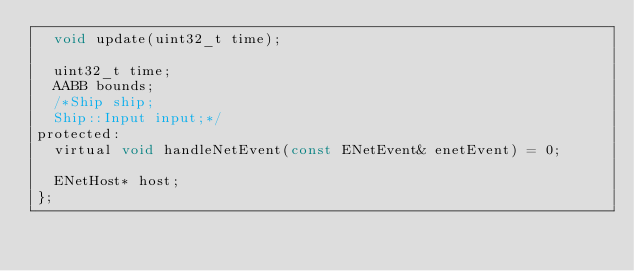Convert code to text. <code><loc_0><loc_0><loc_500><loc_500><_C_>	void update(uint32_t time);

	uint32_t time;
	AABB bounds;
	/*Ship ship;
	Ship::Input input;*/
protected:
	virtual void handleNetEvent(const ENetEvent& enetEvent) = 0;

	ENetHost* host;
};
</code> 